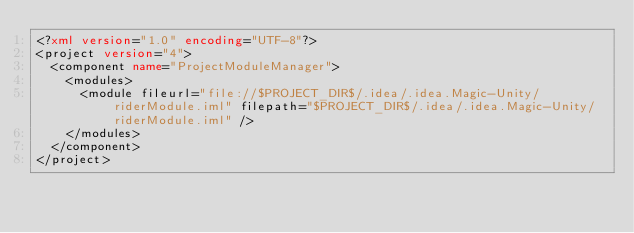Convert code to text. <code><loc_0><loc_0><loc_500><loc_500><_XML_><?xml version="1.0" encoding="UTF-8"?>
<project version="4">
  <component name="ProjectModuleManager">
    <modules>
      <module fileurl="file://$PROJECT_DIR$/.idea/.idea.Magic-Unity/riderModule.iml" filepath="$PROJECT_DIR$/.idea/.idea.Magic-Unity/riderModule.iml" />
    </modules>
  </component>
</project></code> 